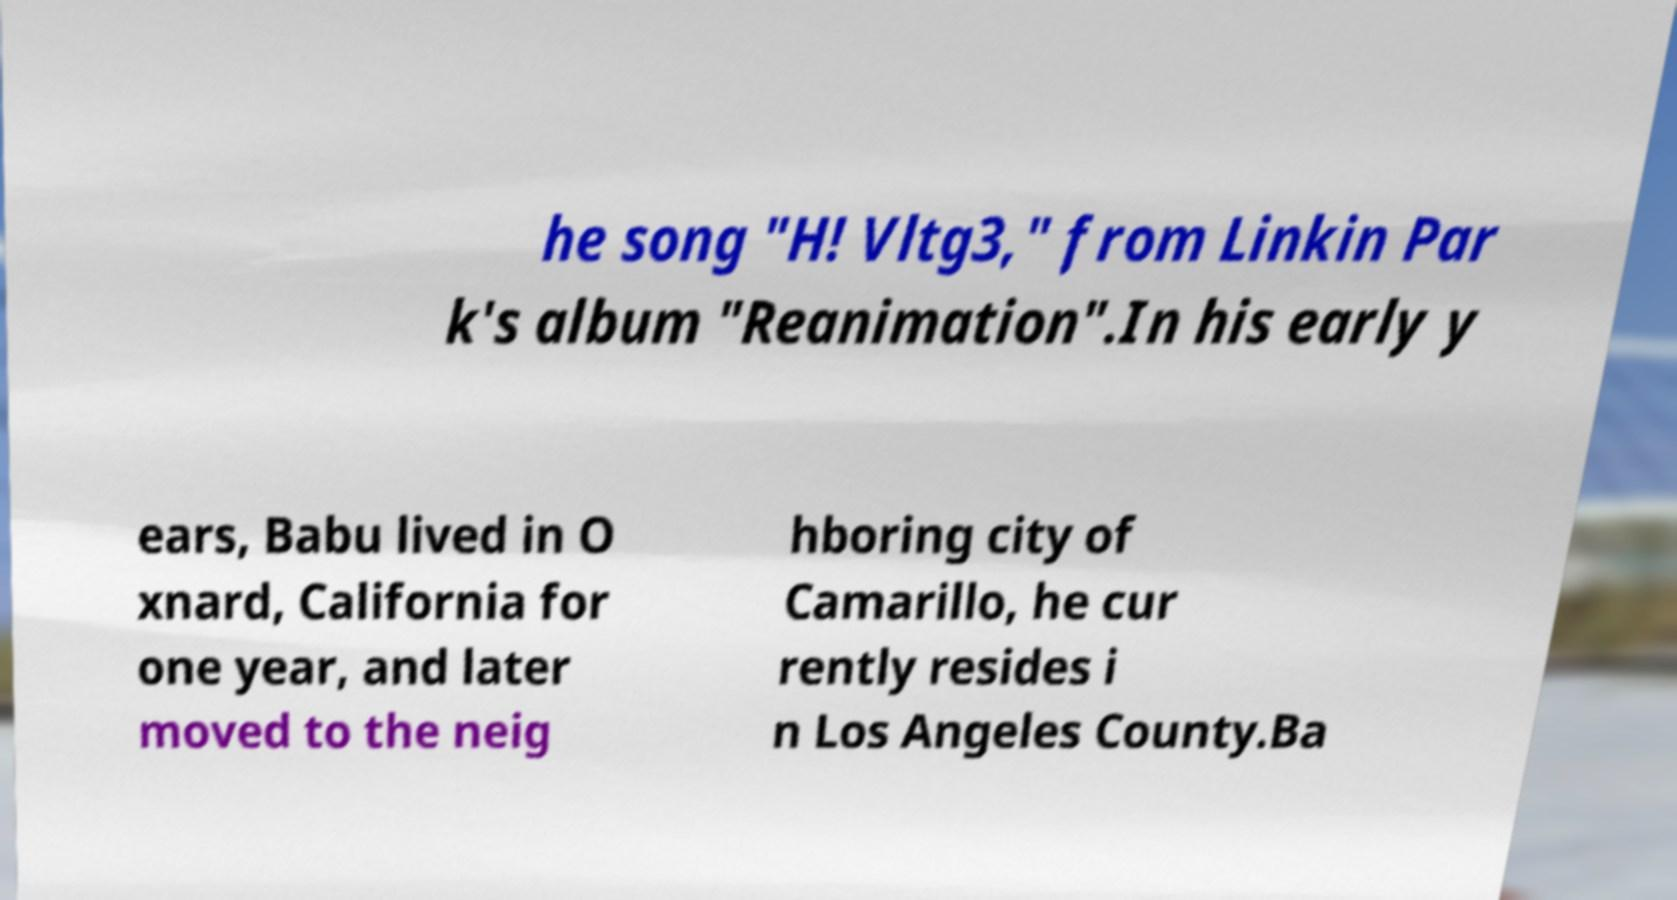Please read and relay the text visible in this image. What does it say? he song "H! Vltg3," from Linkin Par k's album "Reanimation".In his early y ears, Babu lived in O xnard, California for one year, and later moved to the neig hboring city of Camarillo, he cur rently resides i n Los Angeles County.Ba 